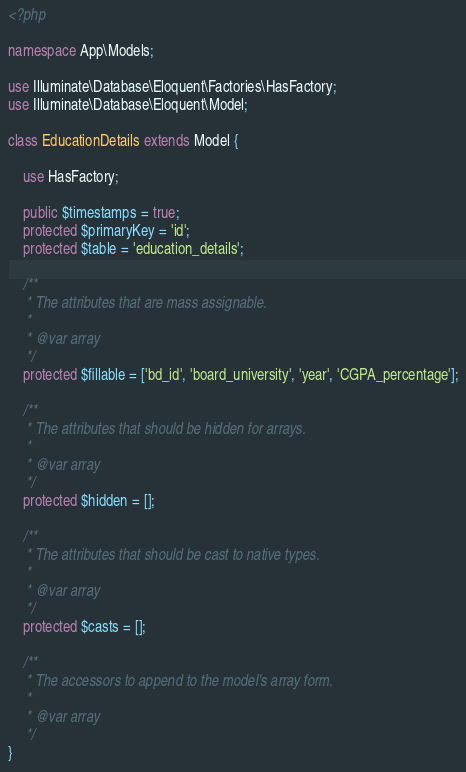Convert code to text. <code><loc_0><loc_0><loc_500><loc_500><_PHP_><?php

namespace App\Models;

use Illuminate\Database\Eloquent\Factories\HasFactory;
use Illuminate\Database\Eloquent\Model;

class EducationDetails extends Model {

    use HasFactory;

    public $timestamps = true;
    protected $primaryKey = 'id';
    protected $table = 'education_details';

    /**
     * The attributes that are mass assignable.
     *
     * @var array
     */
    protected $fillable = ['bd_id', 'board_university', 'year', 'CGPA_percentage'];

    /**
     * The attributes that should be hidden for arrays.
     *
     * @var array
     */
    protected $hidden = [];

    /**
     * The attributes that should be cast to native types.
     *
     * @var array
     */
    protected $casts = [];

    /**
     * The accessors to append to the model's array form.
     *
     * @var array
     */
}
</code> 